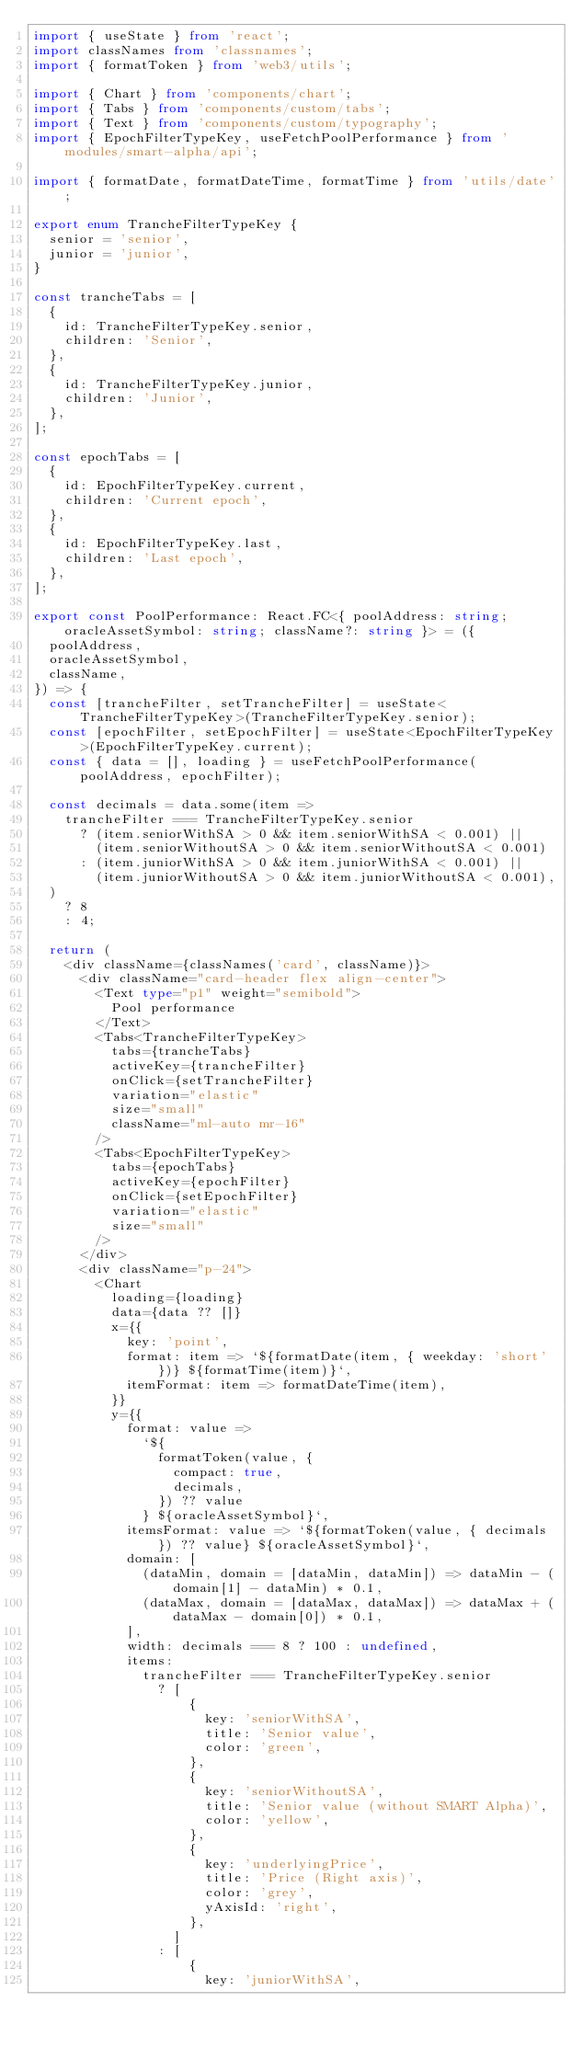<code> <loc_0><loc_0><loc_500><loc_500><_TypeScript_>import { useState } from 'react';
import classNames from 'classnames';
import { formatToken } from 'web3/utils';

import { Chart } from 'components/chart';
import { Tabs } from 'components/custom/tabs';
import { Text } from 'components/custom/typography';
import { EpochFilterTypeKey, useFetchPoolPerformance } from 'modules/smart-alpha/api';

import { formatDate, formatDateTime, formatTime } from 'utils/date';

export enum TrancheFilterTypeKey {
  senior = 'senior',
  junior = 'junior',
}

const trancheTabs = [
  {
    id: TrancheFilterTypeKey.senior,
    children: 'Senior',
  },
  {
    id: TrancheFilterTypeKey.junior,
    children: 'Junior',
  },
];

const epochTabs = [
  {
    id: EpochFilterTypeKey.current,
    children: 'Current epoch',
  },
  {
    id: EpochFilterTypeKey.last,
    children: 'Last epoch',
  },
];

export const PoolPerformance: React.FC<{ poolAddress: string; oracleAssetSymbol: string; className?: string }> = ({
  poolAddress,
  oracleAssetSymbol,
  className,
}) => {
  const [trancheFilter, setTrancheFilter] = useState<TrancheFilterTypeKey>(TrancheFilterTypeKey.senior);
  const [epochFilter, setEpochFilter] = useState<EpochFilterTypeKey>(EpochFilterTypeKey.current);
  const { data = [], loading } = useFetchPoolPerformance(poolAddress, epochFilter);

  const decimals = data.some(item =>
    trancheFilter === TrancheFilterTypeKey.senior
      ? (item.seniorWithSA > 0 && item.seniorWithSA < 0.001) ||
        (item.seniorWithoutSA > 0 && item.seniorWithoutSA < 0.001)
      : (item.juniorWithSA > 0 && item.juniorWithSA < 0.001) ||
        (item.juniorWithoutSA > 0 && item.juniorWithoutSA < 0.001),
  )
    ? 8
    : 4;

  return (
    <div className={classNames('card', className)}>
      <div className="card-header flex align-center">
        <Text type="p1" weight="semibold">
          Pool performance
        </Text>
        <Tabs<TrancheFilterTypeKey>
          tabs={trancheTabs}
          activeKey={trancheFilter}
          onClick={setTrancheFilter}
          variation="elastic"
          size="small"
          className="ml-auto mr-16"
        />
        <Tabs<EpochFilterTypeKey>
          tabs={epochTabs}
          activeKey={epochFilter}
          onClick={setEpochFilter}
          variation="elastic"
          size="small"
        />
      </div>
      <div className="p-24">
        <Chart
          loading={loading}
          data={data ?? []}
          x={{
            key: 'point',
            format: item => `${formatDate(item, { weekday: 'short' })} ${formatTime(item)}`,
            itemFormat: item => formatDateTime(item),
          }}
          y={{
            format: value =>
              `${
                formatToken(value, {
                  compact: true,
                  decimals,
                }) ?? value
              } ${oracleAssetSymbol}`,
            itemsFormat: value => `${formatToken(value, { decimals }) ?? value} ${oracleAssetSymbol}`,
            domain: [
              (dataMin, domain = [dataMin, dataMin]) => dataMin - (domain[1] - dataMin) * 0.1,
              (dataMax, domain = [dataMax, dataMax]) => dataMax + (dataMax - domain[0]) * 0.1,
            ],
            width: decimals === 8 ? 100 : undefined,
            items:
              trancheFilter === TrancheFilterTypeKey.senior
                ? [
                    {
                      key: 'seniorWithSA',
                      title: 'Senior value',
                      color: 'green',
                    },
                    {
                      key: 'seniorWithoutSA',
                      title: 'Senior value (without SMART Alpha)',
                      color: 'yellow',
                    },
                    {
                      key: 'underlyingPrice',
                      title: 'Price (Right axis)',
                      color: 'grey',
                      yAxisId: 'right',
                    },
                  ]
                : [
                    {
                      key: 'juniorWithSA',</code> 